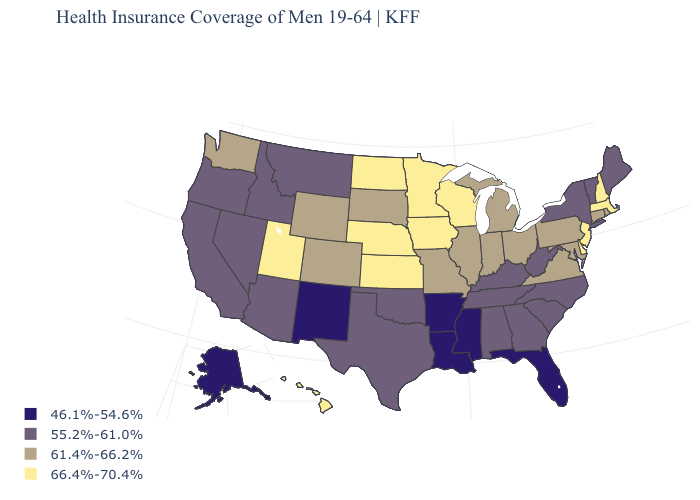What is the value of Vermont?
Give a very brief answer. 55.2%-61.0%. Does the map have missing data?
Short answer required. No. What is the value of Wisconsin?
Quick response, please. 66.4%-70.4%. What is the value of Indiana?
Write a very short answer. 61.4%-66.2%. Does Washington have the highest value in the West?
Give a very brief answer. No. What is the value of Vermont?
Write a very short answer. 55.2%-61.0%. Name the states that have a value in the range 46.1%-54.6%?
Be succinct. Alaska, Arkansas, Florida, Louisiana, Mississippi, New Mexico. Does Minnesota have the highest value in the USA?
Concise answer only. Yes. Name the states that have a value in the range 61.4%-66.2%?
Give a very brief answer. Colorado, Connecticut, Illinois, Indiana, Maryland, Michigan, Missouri, Ohio, Pennsylvania, Rhode Island, South Dakota, Virginia, Washington, Wyoming. What is the highest value in states that border South Dakota?
Keep it brief. 66.4%-70.4%. Which states have the lowest value in the USA?
Write a very short answer. Alaska, Arkansas, Florida, Louisiana, Mississippi, New Mexico. Which states have the highest value in the USA?
Write a very short answer. Delaware, Hawaii, Iowa, Kansas, Massachusetts, Minnesota, Nebraska, New Hampshire, New Jersey, North Dakota, Utah, Wisconsin. Name the states that have a value in the range 61.4%-66.2%?
Quick response, please. Colorado, Connecticut, Illinois, Indiana, Maryland, Michigan, Missouri, Ohio, Pennsylvania, Rhode Island, South Dakota, Virginia, Washington, Wyoming. Among the states that border Maryland , does West Virginia have the lowest value?
Concise answer only. Yes. What is the value of Virginia?
Write a very short answer. 61.4%-66.2%. 